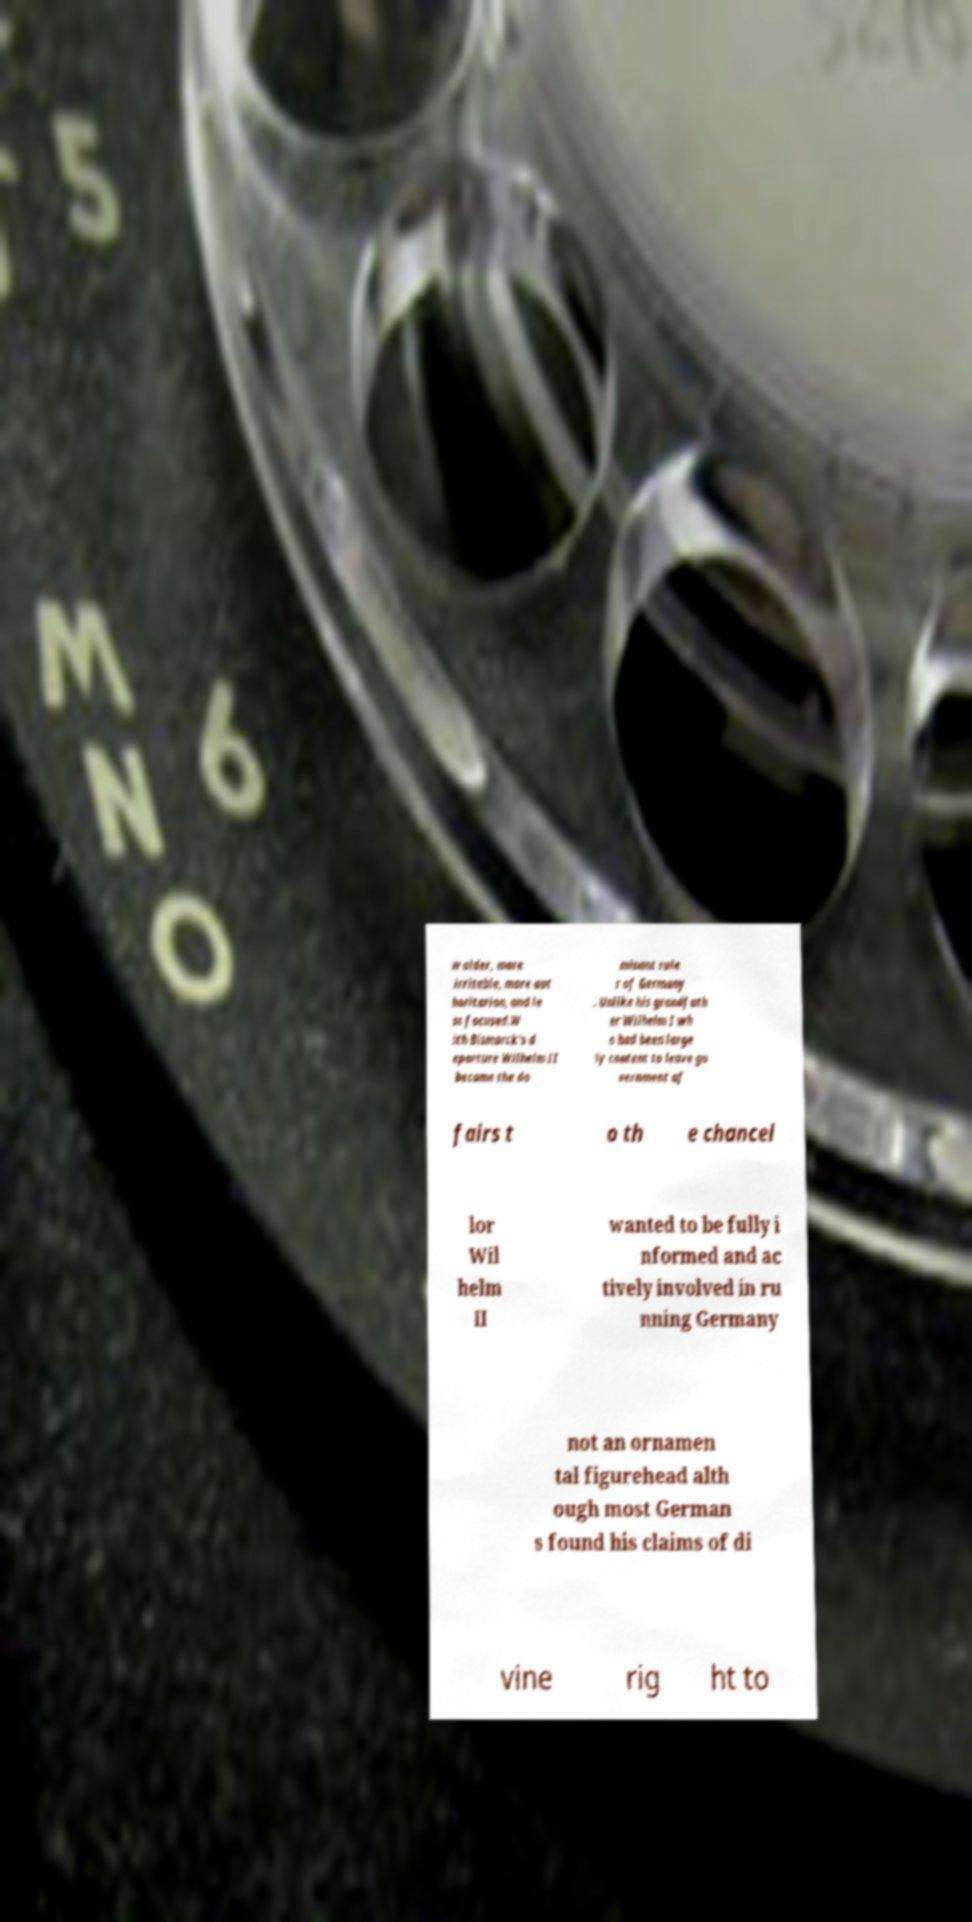I need the written content from this picture converted into text. Can you do that? w older, more irritable, more aut horitarian, and le ss focused.W ith Bismarck's d eparture Wilhelm II became the do minant rule r of Germany . Unlike his grandfath er Wilhelm I wh o had been large ly content to leave go vernment af fairs t o th e chancel lor Wil helm II wanted to be fully i nformed and ac tively involved in ru nning Germany not an ornamen tal figurehead alth ough most German s found his claims of di vine rig ht to 